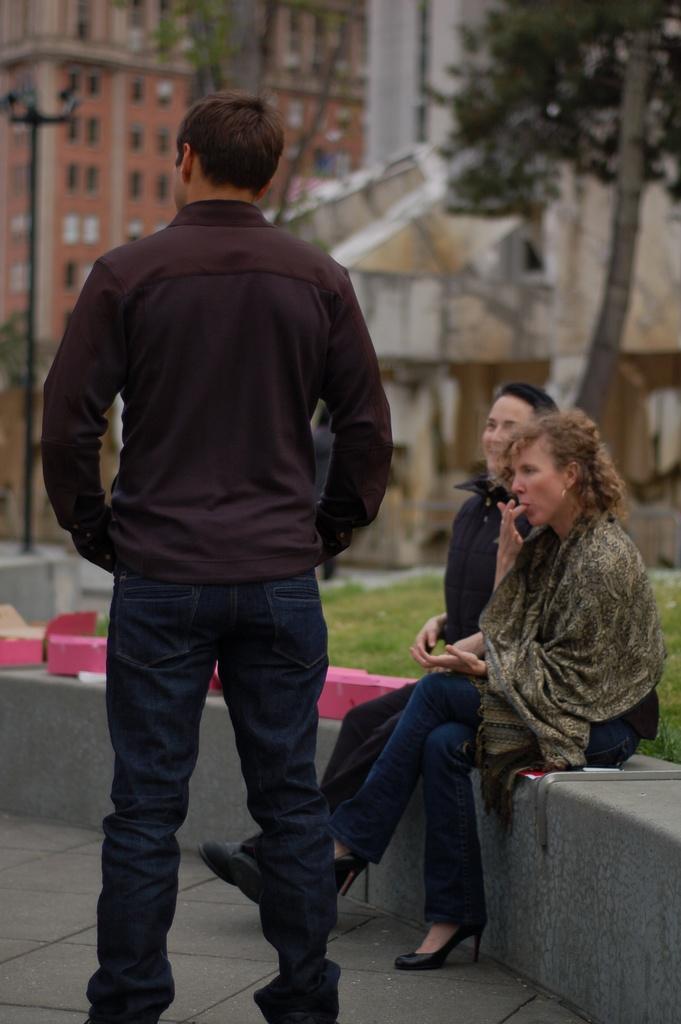Could you give a brief overview of what you see in this image? In this image in the foreground there is one man who is standing, and on the right side there are two women who are sitting. And in the background there are some houses, trees and a pole at the bottom there is a walkway. And in the center there is some grass and some boxes. 